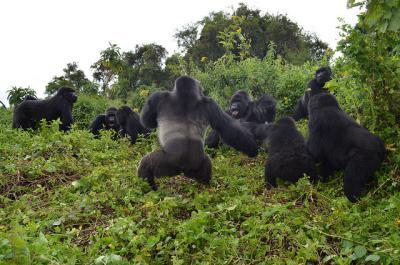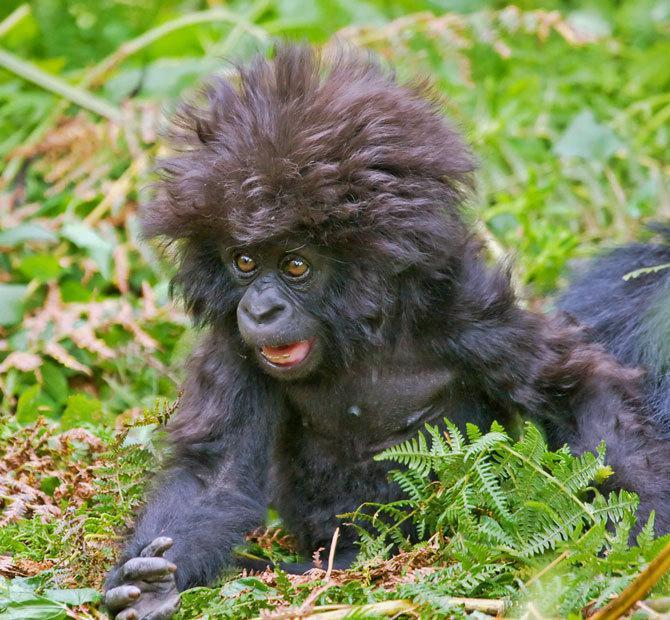The first image is the image on the left, the second image is the image on the right. Evaluate the accuracy of this statement regarding the images: "An image contains a single gorilla with brown eyes and soft-looking hair.". Is it true? Answer yes or no. Yes. 